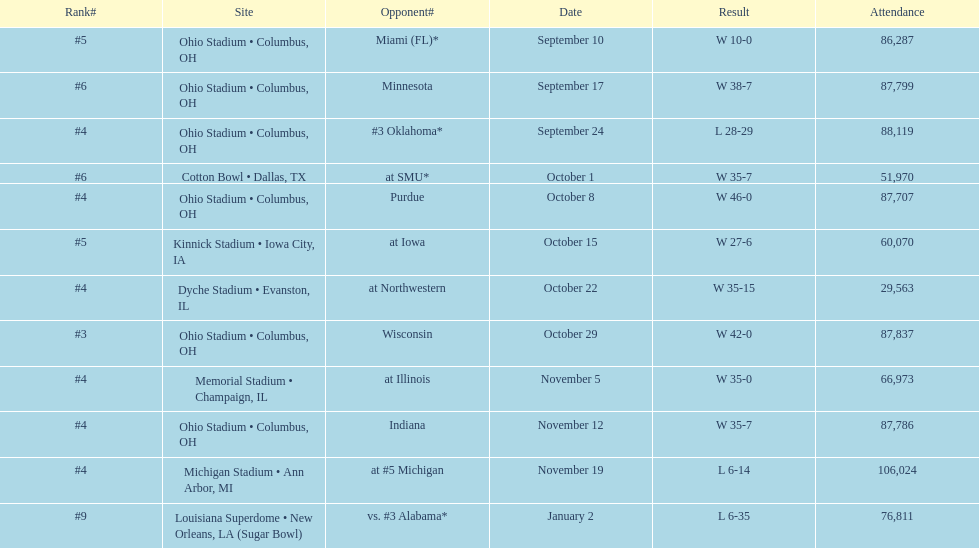Which date was attended by the most people? November 19. 